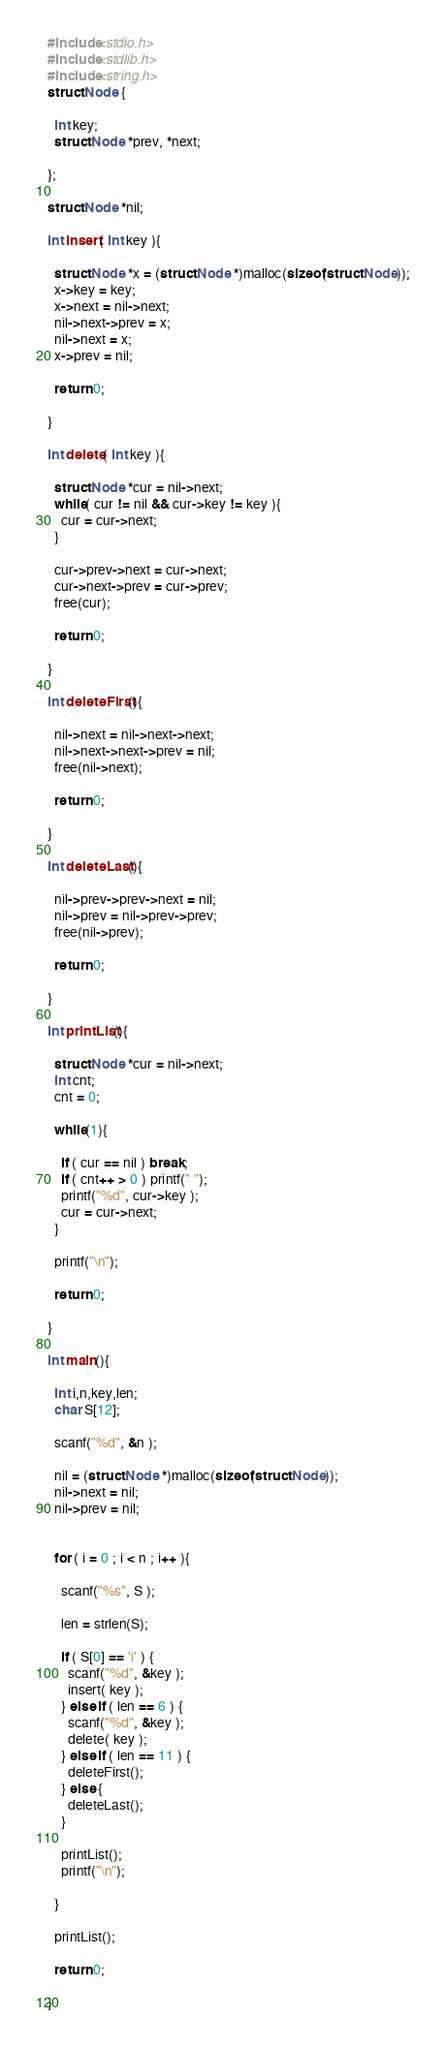<code> <loc_0><loc_0><loc_500><loc_500><_C_>#include<stdio.h>
#include<stdlib.h>
#include<string.h>
struct Node {

  int key;
  struct Node *prev, *next;

};

struct Node *nil;

int insert( int key ){

  struct Node *x = (struct Node *)malloc(sizeof(struct Node));
  x->key = key;
  x->next = nil->next;
  nil->next->prev = x;
  nil->next = x;
  x->prev = nil;

  return 0;

}

int delete( int key ){

  struct Node *cur = nil->next;
  while( cur != nil && cur->key != key ){
    cur = cur->next;
  }

  cur->prev->next = cur->next;
  cur->next->prev = cur->prev;
  free(cur);

  return 0;

}

int deleteFirst(){

  nil->next = nil->next->next;
  nil->next->next->prev = nil;
  free(nil->next);

  return 0;
  
}

int deleteLast(){

  nil->prev->prev->next = nil;
  nil->prev = nil->prev->prev;
  free(nil->prev);

  return 0;

}

int printList(){

  struct Node *cur = nil->next;
  int cnt;
  cnt = 0;

  while(1){

    if ( cur == nil ) break;
    if ( cnt++ > 0 ) printf(" ");
    printf("%d", cur->key );
    cur = cur->next;
  }

  printf("\n");

  return 0;

}

int main(){

  int i,n,key,len;
  char S[12];

  scanf("%d", &n );
  
  nil = (struct Node *)malloc(sizeof(struct Node));
  nil->next = nil;
  nil->prev = nil;
  

  for ( i = 0 ; i < n ; i++ ){

    scanf("%s", S );

    len = strlen(S);

    if ( S[0] == 'i' ) {
      scanf("%d", &key );
      insert( key );
    } else if ( len == 6 ) {
      scanf("%d", &key );
      delete( key );
    } else if ( len == 11 ) {
      deleteFirst();	
    } else {
      deleteLast();
    }

    printList();
    printf("\n");
    
  }

  printList();
  
  return 0;

}</code> 